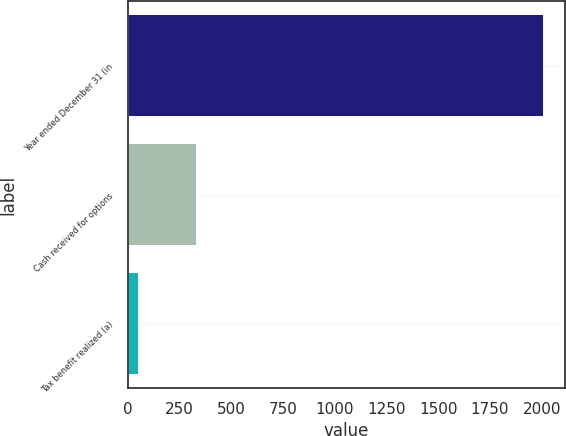Convert chart to OTSL. <chart><loc_0><loc_0><loc_500><loc_500><bar_chart><fcel>Year ended December 31 (in<fcel>Cash received for options<fcel>Tax benefit realized (a)<nl><fcel>2012<fcel>333<fcel>53<nl></chart> 